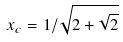<formula> <loc_0><loc_0><loc_500><loc_500>x _ { c } = 1 / \sqrt { 2 + \sqrt { 2 } }</formula> 